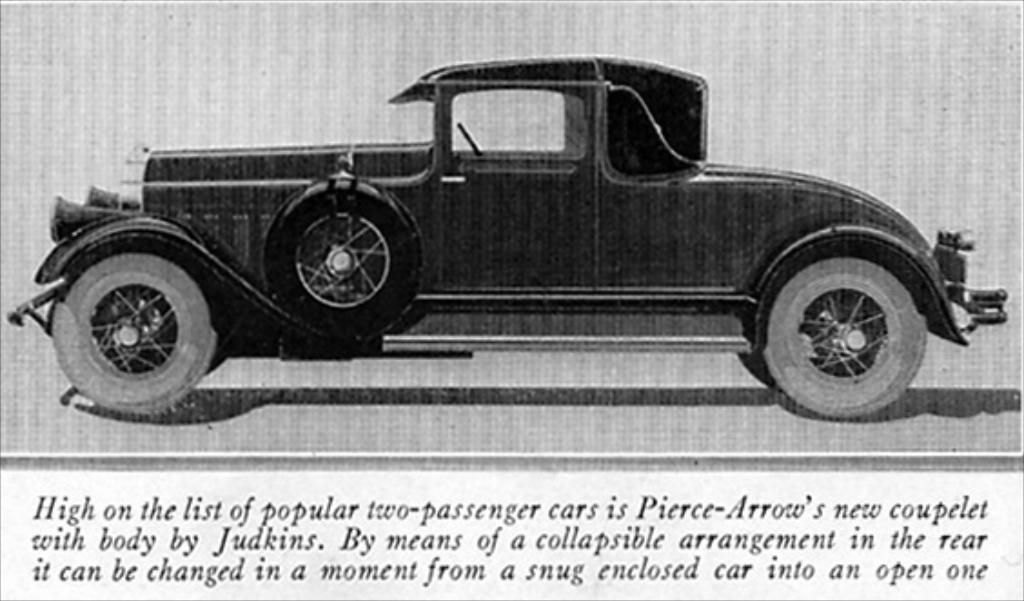Describe this image in one or two sentences. Here in this picture we can see picture of a car printed on a paper and below that we can see some text printed. 